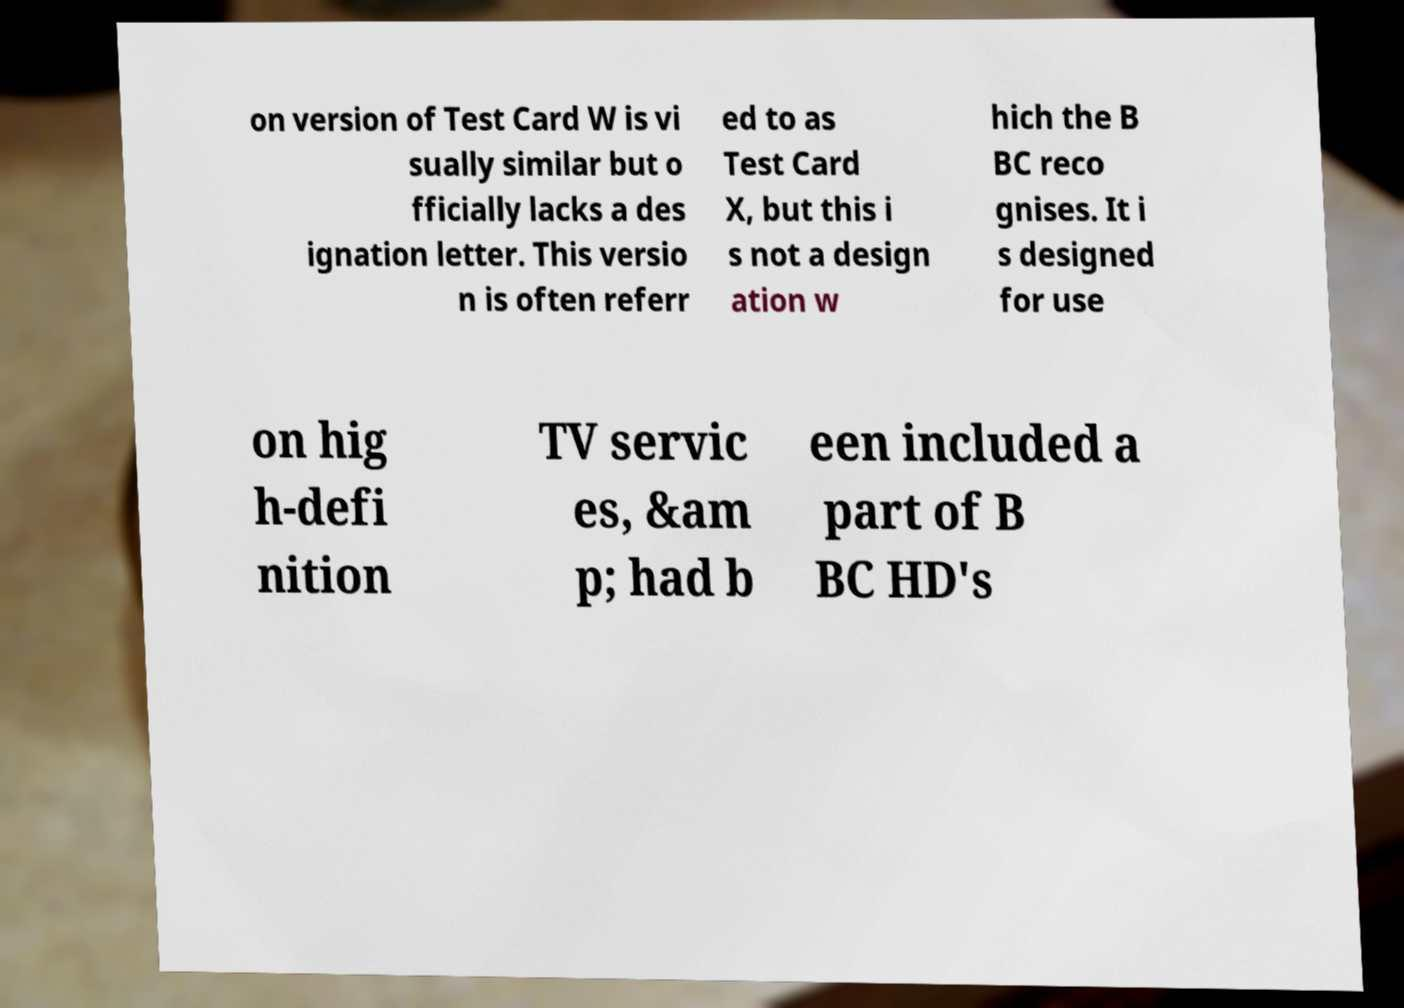For documentation purposes, I need the text within this image transcribed. Could you provide that? on version of Test Card W is vi sually similar but o fficially lacks a des ignation letter. This versio n is often referr ed to as Test Card X, but this i s not a design ation w hich the B BC reco gnises. It i s designed for use on hig h-defi nition TV servic es, &am p; had b een included a part of B BC HD's 